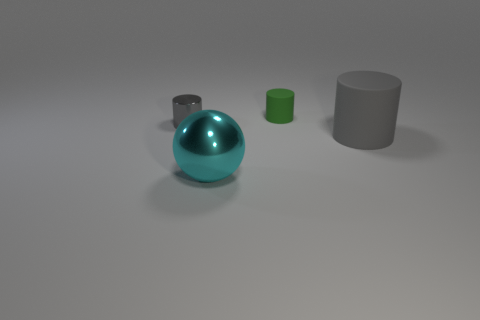How would the texture of the large sphere differ from the texture of the two cylinders? The large sphere exhibits a glossy, reflective texture, suggesting it has a smooth and possibly polished surface. On the other hand, the cylinder to the left appears to have a similar reflective quality, while the tiny green cylinder seems to have a more matte texture, thereby lacking the shiny aspect of the larger sphere and the other cylinder. 